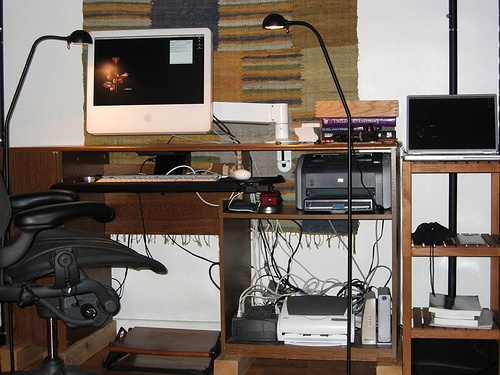Describe the objects in this image and their specific colors. I can see chair in black, gray, and purple tones, tv in black, lightgray, darkgray, and tan tones, laptop in black, white, darkgray, and gray tones, tv in black, gray, and darkgray tones, and book in black, gray, lightgray, and darkgray tones in this image. 